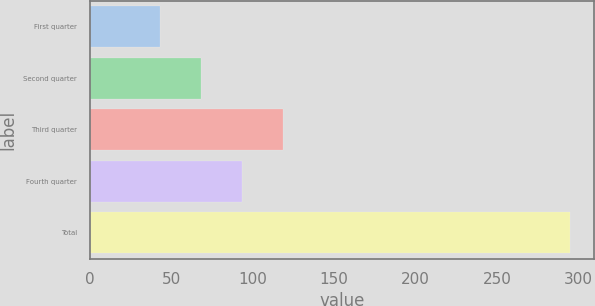<chart> <loc_0><loc_0><loc_500><loc_500><bar_chart><fcel>First quarter<fcel>Second quarter<fcel>Third quarter<fcel>Fourth quarter<fcel>Total<nl><fcel>43<fcel>68.2<fcel>118.6<fcel>93.4<fcel>295<nl></chart> 